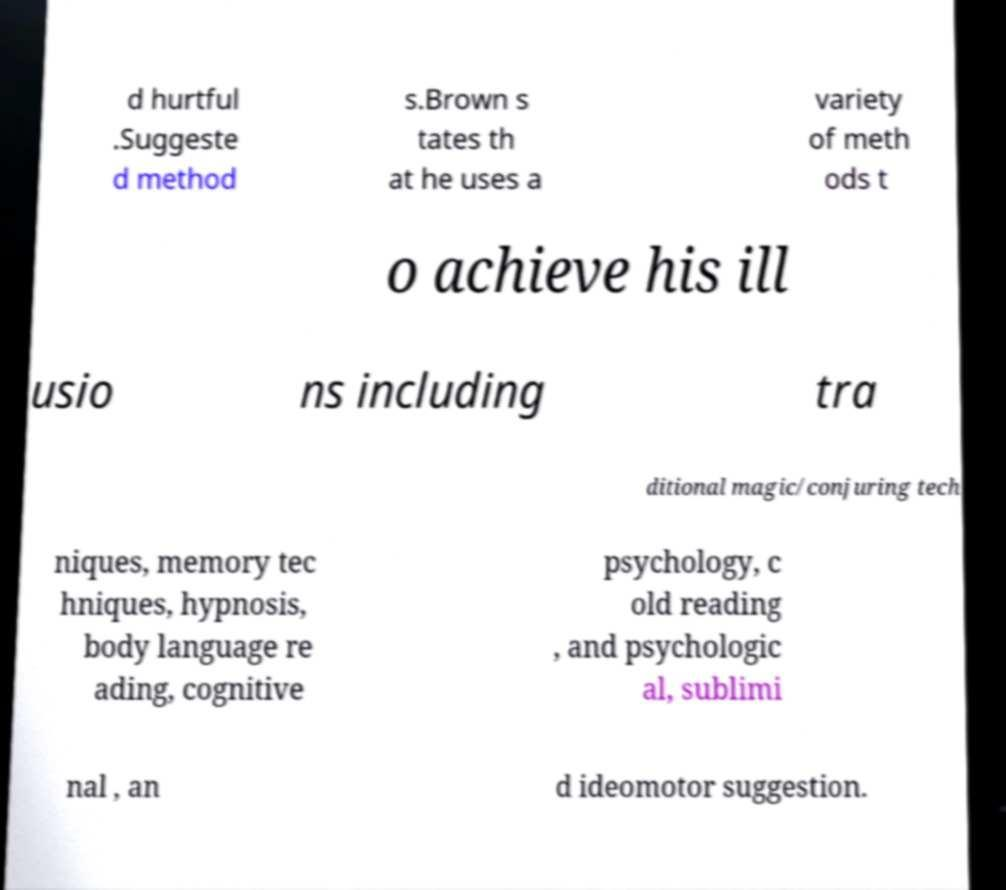Can you accurately transcribe the text from the provided image for me? d hurtful .Suggeste d method s.Brown s tates th at he uses a variety of meth ods t o achieve his ill usio ns including tra ditional magic/conjuring tech niques, memory tec hniques, hypnosis, body language re ading, cognitive psychology, c old reading , and psychologic al, sublimi nal , an d ideomotor suggestion. 